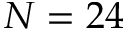<formula> <loc_0><loc_0><loc_500><loc_500>N = 2 4</formula> 